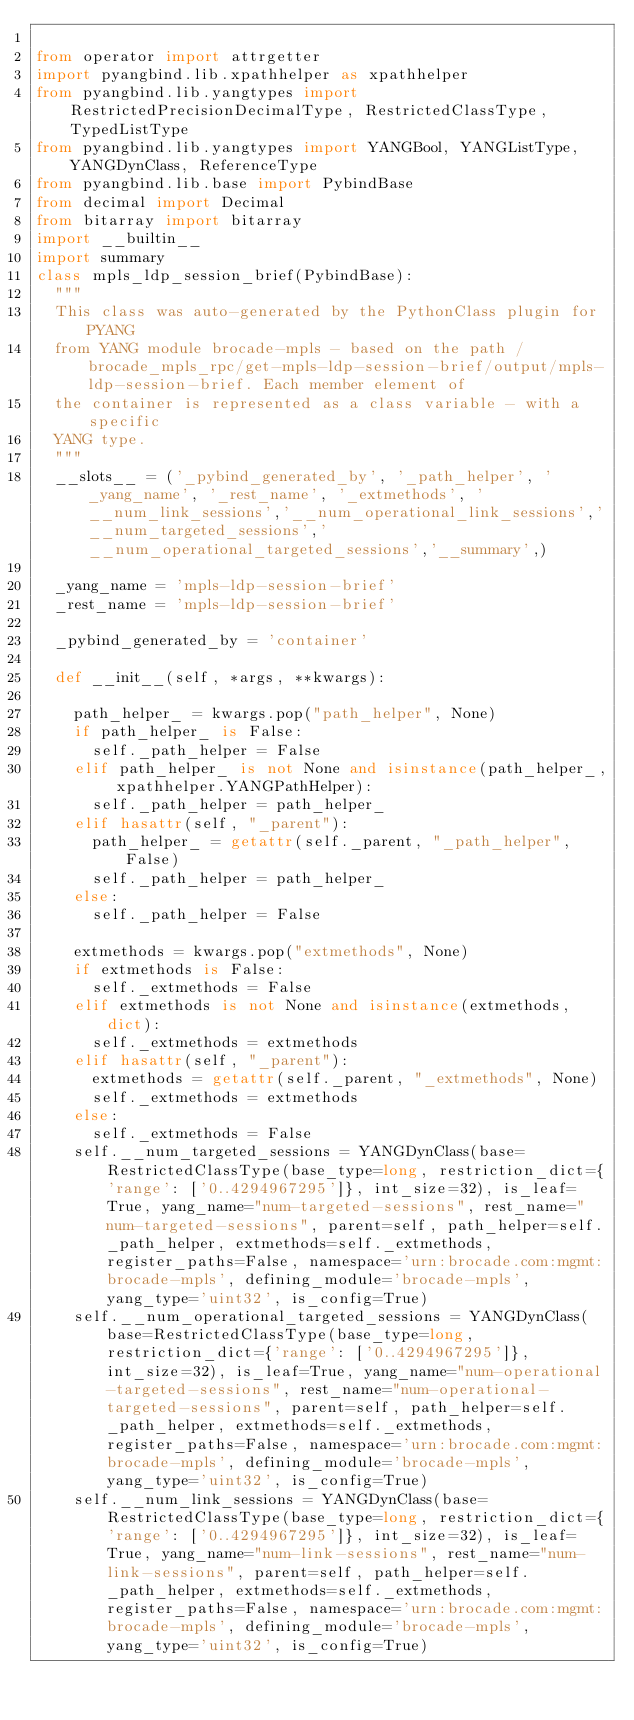<code> <loc_0><loc_0><loc_500><loc_500><_Python_>
from operator import attrgetter
import pyangbind.lib.xpathhelper as xpathhelper
from pyangbind.lib.yangtypes import RestrictedPrecisionDecimalType, RestrictedClassType, TypedListType
from pyangbind.lib.yangtypes import YANGBool, YANGListType, YANGDynClass, ReferenceType
from pyangbind.lib.base import PybindBase
from decimal import Decimal
from bitarray import bitarray
import __builtin__
import summary
class mpls_ldp_session_brief(PybindBase):
  """
  This class was auto-generated by the PythonClass plugin for PYANG
  from YANG module brocade-mpls - based on the path /brocade_mpls_rpc/get-mpls-ldp-session-brief/output/mpls-ldp-session-brief. Each member element of
  the container is represented as a class variable - with a specific
  YANG type.
  """
  __slots__ = ('_pybind_generated_by', '_path_helper', '_yang_name', '_rest_name', '_extmethods', '__num_link_sessions','__num_operational_link_sessions','__num_targeted_sessions','__num_operational_targeted_sessions','__summary',)

  _yang_name = 'mpls-ldp-session-brief'
  _rest_name = 'mpls-ldp-session-brief'

  _pybind_generated_by = 'container'

  def __init__(self, *args, **kwargs):

    path_helper_ = kwargs.pop("path_helper", None)
    if path_helper_ is False:
      self._path_helper = False
    elif path_helper_ is not None and isinstance(path_helper_, xpathhelper.YANGPathHelper):
      self._path_helper = path_helper_
    elif hasattr(self, "_parent"):
      path_helper_ = getattr(self._parent, "_path_helper", False)
      self._path_helper = path_helper_
    else:
      self._path_helper = False

    extmethods = kwargs.pop("extmethods", None)
    if extmethods is False:
      self._extmethods = False
    elif extmethods is not None and isinstance(extmethods, dict):
      self._extmethods = extmethods
    elif hasattr(self, "_parent"):
      extmethods = getattr(self._parent, "_extmethods", None)
      self._extmethods = extmethods
    else:
      self._extmethods = False
    self.__num_targeted_sessions = YANGDynClass(base=RestrictedClassType(base_type=long, restriction_dict={'range': ['0..4294967295']}, int_size=32), is_leaf=True, yang_name="num-targeted-sessions", rest_name="num-targeted-sessions", parent=self, path_helper=self._path_helper, extmethods=self._extmethods, register_paths=False, namespace='urn:brocade.com:mgmt:brocade-mpls', defining_module='brocade-mpls', yang_type='uint32', is_config=True)
    self.__num_operational_targeted_sessions = YANGDynClass(base=RestrictedClassType(base_type=long, restriction_dict={'range': ['0..4294967295']}, int_size=32), is_leaf=True, yang_name="num-operational-targeted-sessions", rest_name="num-operational-targeted-sessions", parent=self, path_helper=self._path_helper, extmethods=self._extmethods, register_paths=False, namespace='urn:brocade.com:mgmt:brocade-mpls', defining_module='brocade-mpls', yang_type='uint32', is_config=True)
    self.__num_link_sessions = YANGDynClass(base=RestrictedClassType(base_type=long, restriction_dict={'range': ['0..4294967295']}, int_size=32), is_leaf=True, yang_name="num-link-sessions", rest_name="num-link-sessions", parent=self, path_helper=self._path_helper, extmethods=self._extmethods, register_paths=False, namespace='urn:brocade.com:mgmt:brocade-mpls', defining_module='brocade-mpls', yang_type='uint32', is_config=True)</code> 